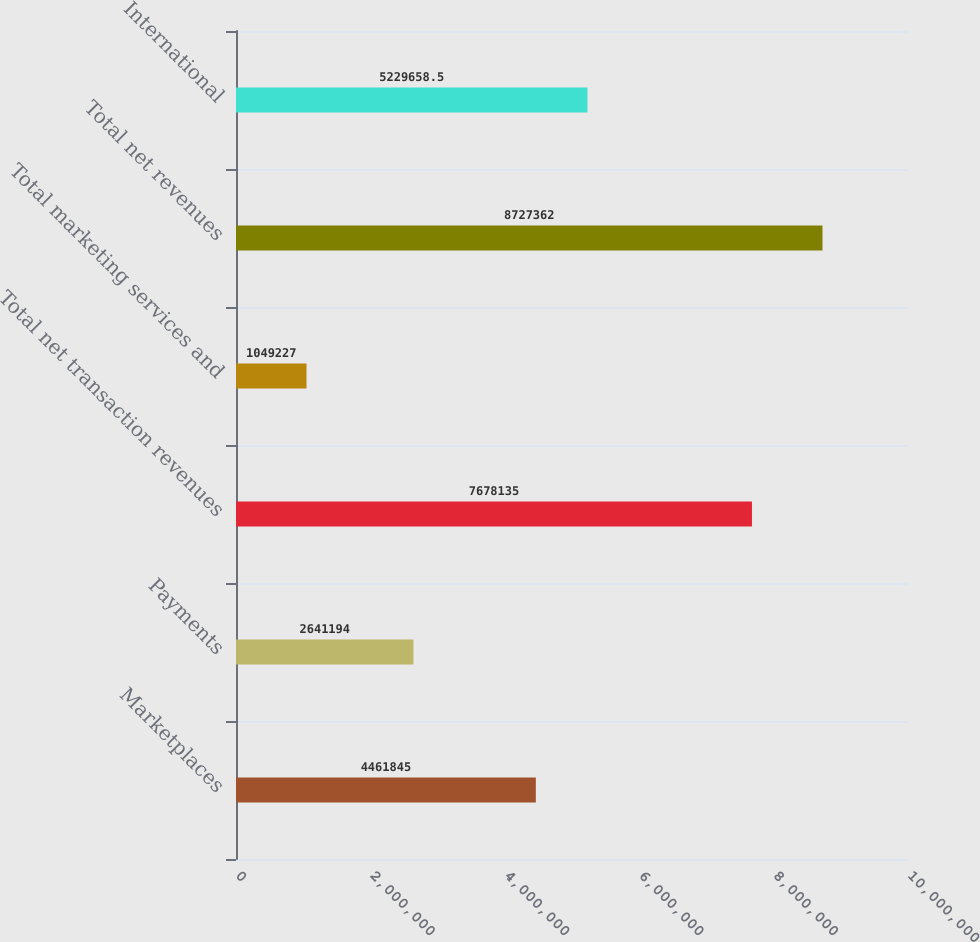<chart> <loc_0><loc_0><loc_500><loc_500><bar_chart><fcel>Marketplaces<fcel>Payments<fcel>Total net transaction revenues<fcel>Total marketing services and<fcel>Total net revenues<fcel>International<nl><fcel>4.46184e+06<fcel>2.64119e+06<fcel>7.67814e+06<fcel>1.04923e+06<fcel>8.72736e+06<fcel>5.22966e+06<nl></chart> 